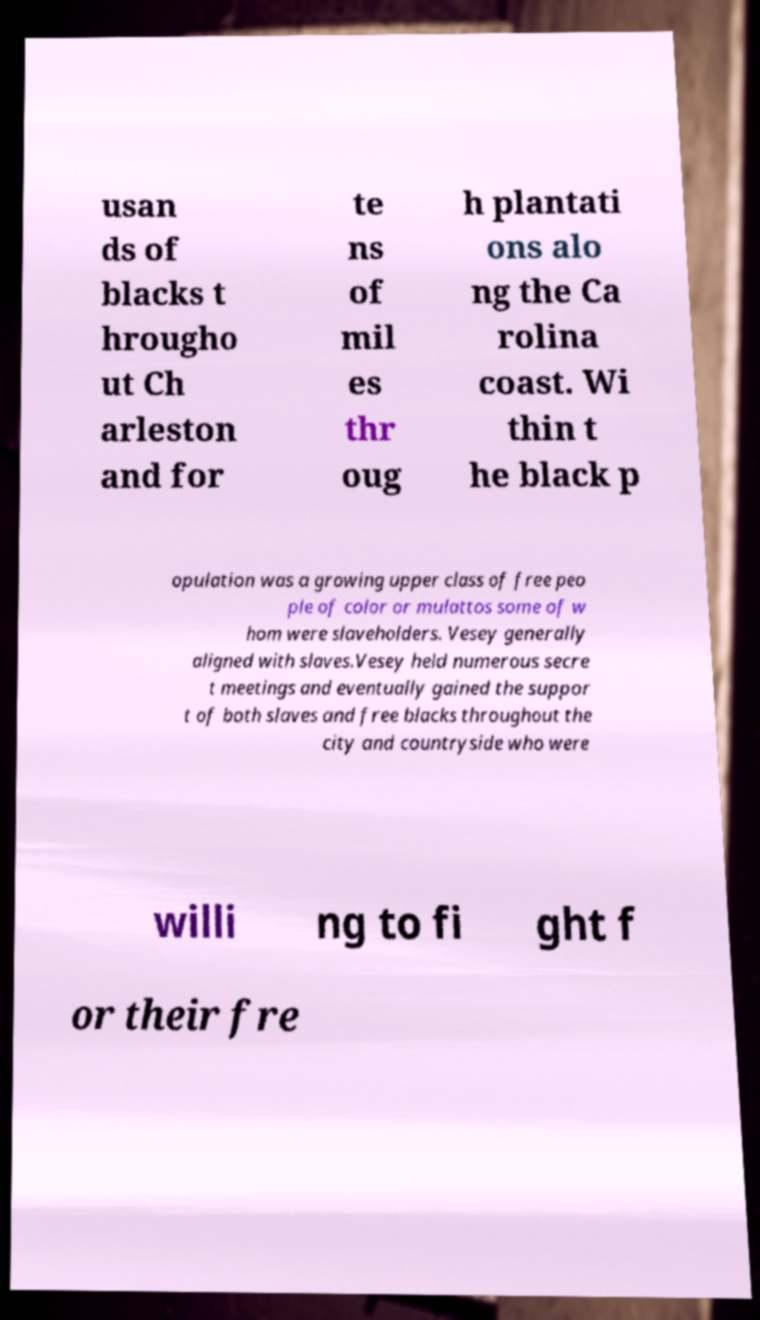Can you accurately transcribe the text from the provided image for me? usan ds of blacks t hrougho ut Ch arleston and for te ns of mil es thr oug h plantati ons alo ng the Ca rolina coast. Wi thin t he black p opulation was a growing upper class of free peo ple of color or mulattos some of w hom were slaveholders. Vesey generally aligned with slaves.Vesey held numerous secre t meetings and eventually gained the suppor t of both slaves and free blacks throughout the city and countryside who were willi ng to fi ght f or their fre 